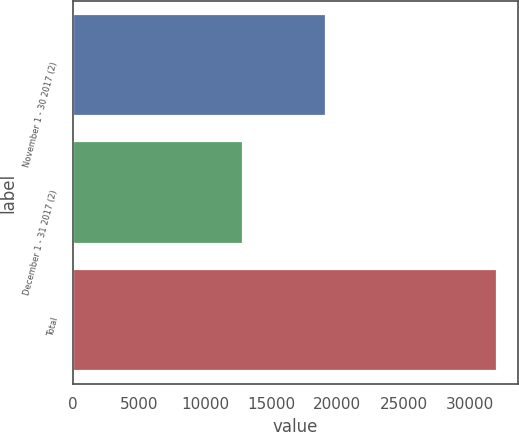Convert chart. <chart><loc_0><loc_0><loc_500><loc_500><bar_chart><fcel>November 1 - 30 2017 (2)<fcel>December 1 - 31 2017 (2)<fcel>Total<nl><fcel>19144<fcel>12901<fcel>32045<nl></chart> 